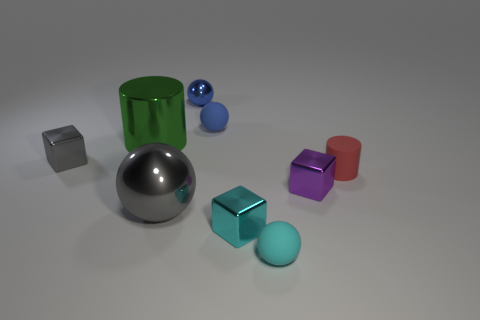What is the material of the block that is right of the small cyan object that is right of the tiny metallic block that is in front of the tiny purple block?
Keep it short and to the point. Metal. There is a tiny ball that is the same material as the green object; what is its color?
Your answer should be very brief. Blue. There is a cylinder that is in front of the small gray thing that is on the left side of the big gray object; what number of metal spheres are behind it?
Your answer should be compact. 1. What material is the small object that is the same color as the large sphere?
Provide a short and direct response. Metal. How many objects are big gray metal things in front of the tiny purple metallic block or large metal spheres?
Give a very brief answer. 1. There is a large object that is in front of the red matte cylinder; is its color the same as the tiny shiny sphere?
Ensure brevity in your answer.  No. There is a small cyan object left of the rubber sphere in front of the small cyan metallic object; what is its shape?
Keep it short and to the point. Cube. Is the number of small things to the left of the red object less than the number of objects on the right side of the big green object?
Offer a terse response. Yes. What size is the other thing that is the same shape as the red rubber object?
Your response must be concise. Large. How many objects are either large things in front of the tiny red cylinder or gray objects right of the shiny cylinder?
Your response must be concise. 1. 